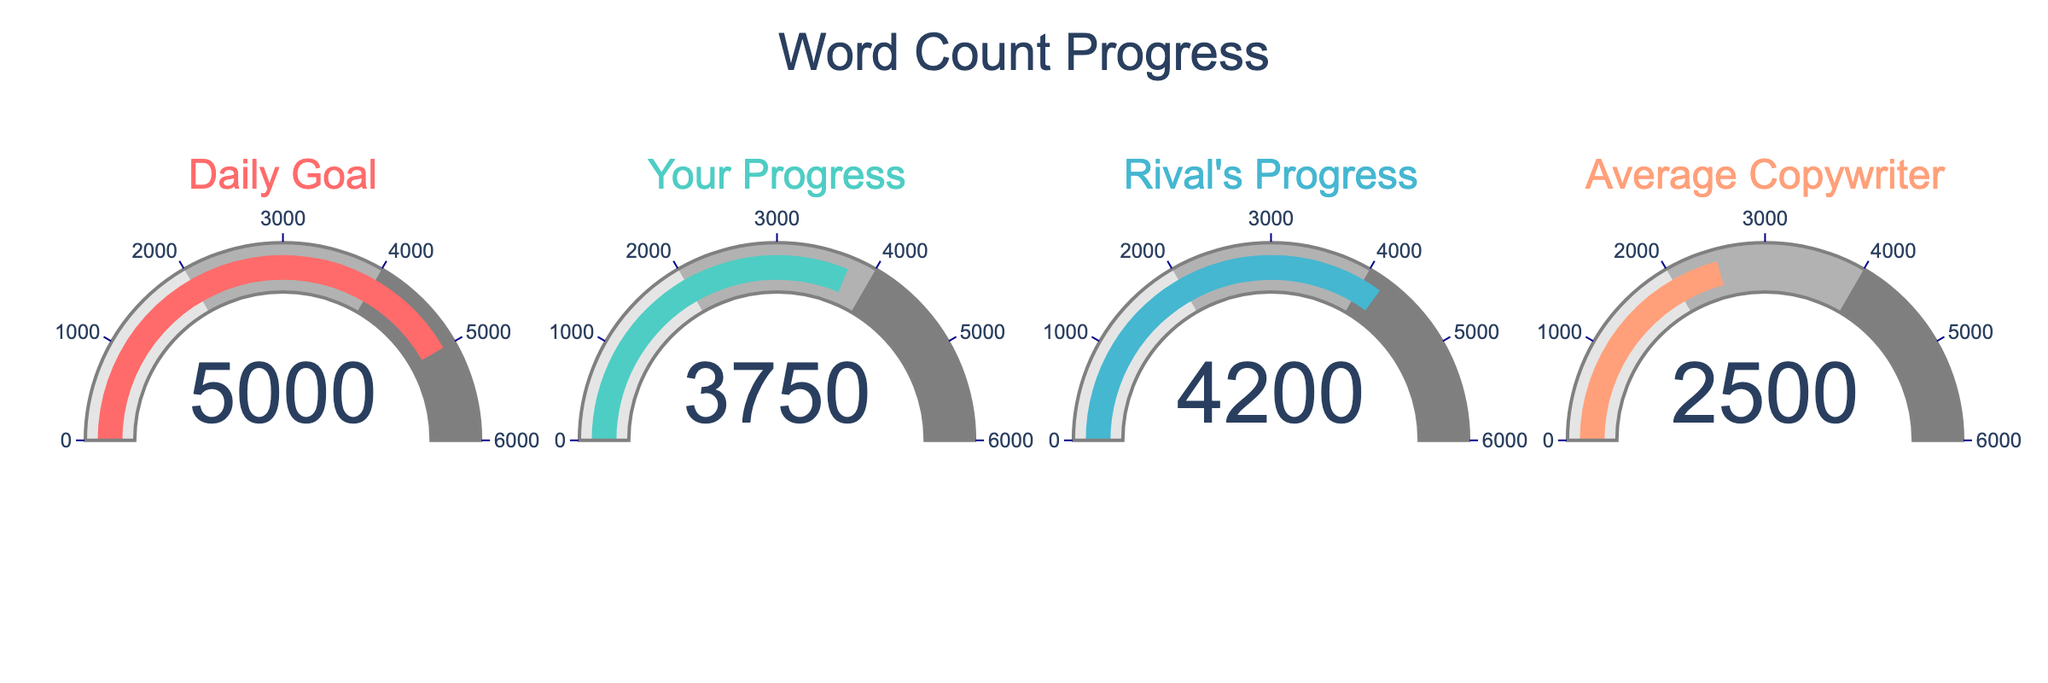What's the title of the chart? The title is clearly located at the top center of the chart and reads "Word Count Progress".
Answer: Word Count Progress How many gauges are displayed on the chart? Each column in the chart represents a single gauge, and there are four columns, thus, there are four gauges.
Answer: Four Which word count represents your progress? Look for the gauge labeled "Your Progress" to locate your word count, which shows a value of 3750.
Answer: 3750 Which progress is higher, yours or your rival's? Compare the gauges labeled "Your Progress" and "Rival's Progress". Your rival's progress gauge shows 4200, which is higher than your progress of 3750.
Answer: Rival's What is the difference between your progress and the daily goal? Subtract your progress (3750) from the daily goal (5000). 5000 - 3750 = 1250.
Answer: 1250 What’s the combined word count of your progress and the average copywriter? Add the values of your progress (3750) and the average copywriter (2500). 3750 + 2500 = 6250.
Answer: 6250 How much more has your rival written compared to the average copywriter? Subtract the average copywriter's progress (2500) from your rival's progress (4200). 4200 - 2500 = 1700.
Answer: 1700 Which gauge has the lowest value? Compare all gauges. The gauge labeled "Average Copywriter" has the lowest value of 2500.
Answer: Average Copywriter By how much does the average copywriter need to increase the word count to reach your progress? Subtract the average copywriter's value (2500) from your progress (3750). 3750 - 2500 = 1250.
Answer: 1250 